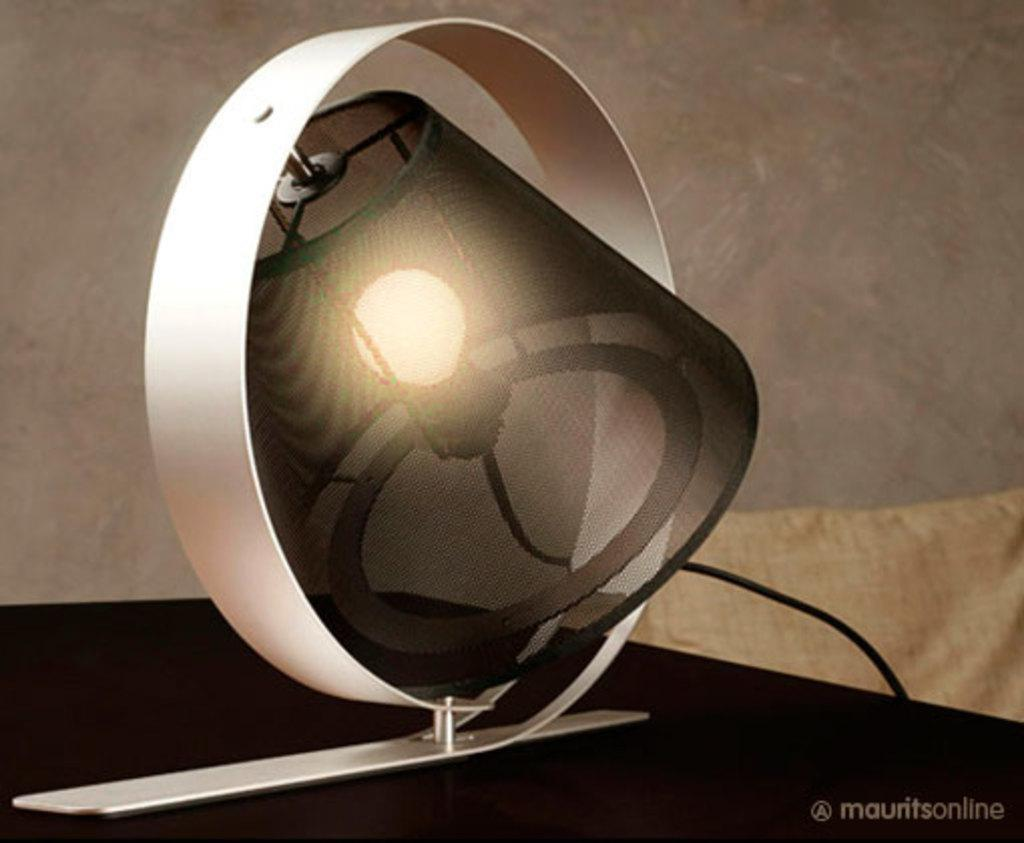What is the main subject of the image? There is a light object in the image. What is the annual income of the stone in the image? There is no stone present in the image, and therefore no income can be attributed to it. 